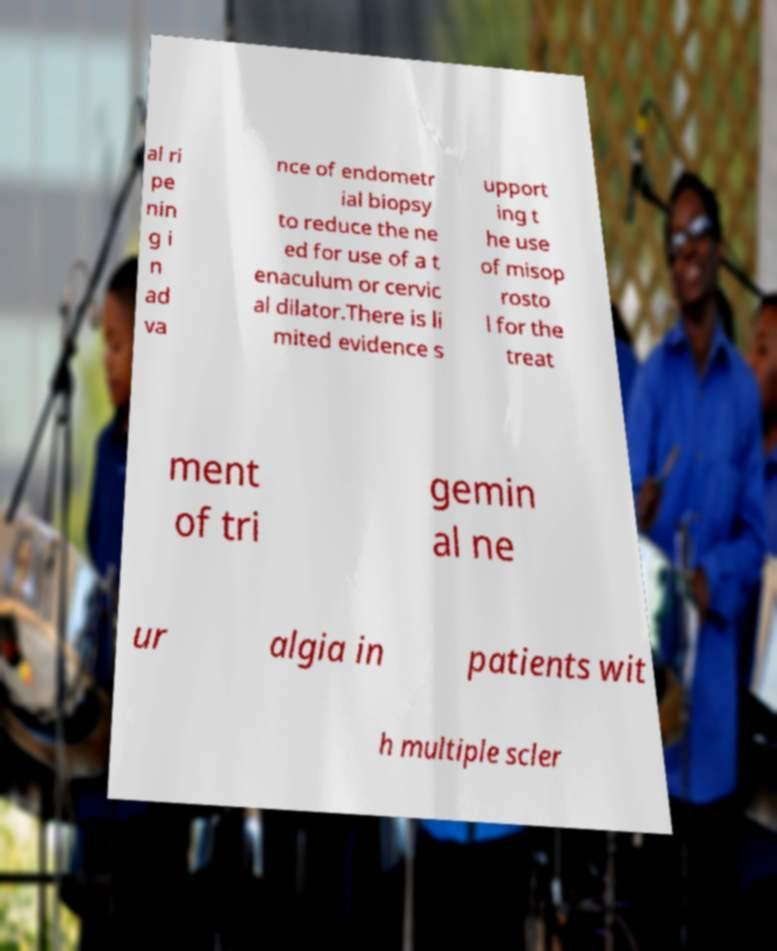Can you read and provide the text displayed in the image?This photo seems to have some interesting text. Can you extract and type it out for me? al ri pe nin g i n ad va nce of endometr ial biopsy to reduce the ne ed for use of a t enaculum or cervic al dilator.There is li mited evidence s upport ing t he use of misop rosto l for the treat ment of tri gemin al ne ur algia in patients wit h multiple scler 